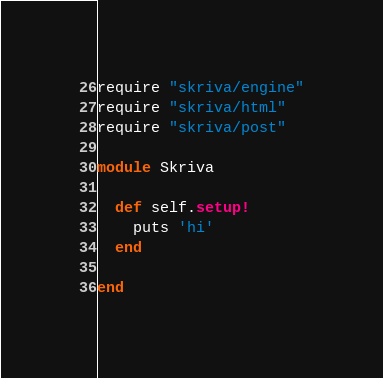<code> <loc_0><loc_0><loc_500><loc_500><_Ruby_>require "skriva/engine"
require "skriva/html"
require "skriva/post"

module Skriva

  def self.setup!
    puts 'hi'
  end

end
</code> 